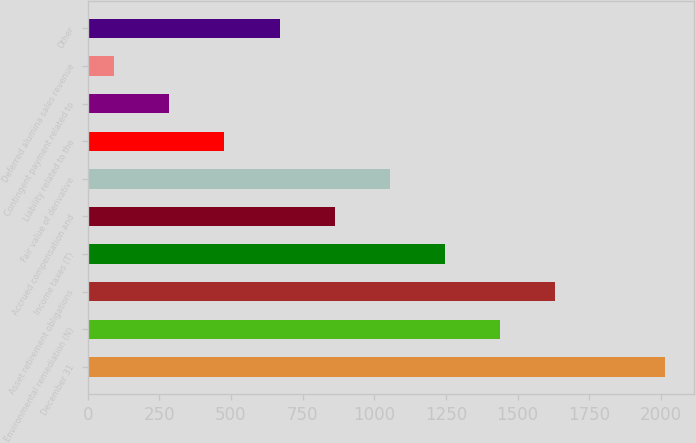<chart> <loc_0><loc_0><loc_500><loc_500><bar_chart><fcel>December 31<fcel>Environmental remediation (N)<fcel>Asset retirement obligations<fcel>Income taxes (T)<fcel>Accrued compensation and<fcel>Fair value of derivative<fcel>Liability related to the<fcel>Contingent payment related to<fcel>Deferred alumina sales revenue<fcel>Other<nl><fcel>2014<fcel>1437.7<fcel>1629.8<fcel>1245.6<fcel>861.4<fcel>1053.5<fcel>477.2<fcel>285.1<fcel>93<fcel>669.3<nl></chart> 